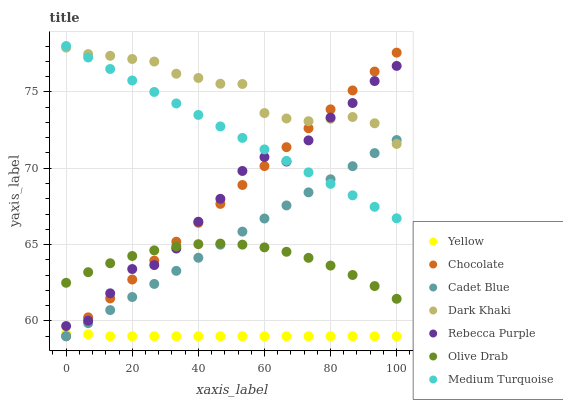Does Yellow have the minimum area under the curve?
Answer yes or no. Yes. Does Dark Khaki have the maximum area under the curve?
Answer yes or no. Yes. Does Chocolate have the minimum area under the curve?
Answer yes or no. No. Does Chocolate have the maximum area under the curve?
Answer yes or no. No. Is Chocolate the smoothest?
Answer yes or no. Yes. Is Rebecca Purple the roughest?
Answer yes or no. Yes. Is Yellow the smoothest?
Answer yes or no. No. Is Yellow the roughest?
Answer yes or no. No. Does Cadet Blue have the lowest value?
Answer yes or no. Yes. Does Dark Khaki have the lowest value?
Answer yes or no. No. Does Medium Turquoise have the highest value?
Answer yes or no. Yes. Does Chocolate have the highest value?
Answer yes or no. No. Is Yellow less than Olive Drab?
Answer yes or no. Yes. Is Rebecca Purple greater than Cadet Blue?
Answer yes or no. Yes. Does Rebecca Purple intersect Olive Drab?
Answer yes or no. Yes. Is Rebecca Purple less than Olive Drab?
Answer yes or no. No. Is Rebecca Purple greater than Olive Drab?
Answer yes or no. No. Does Yellow intersect Olive Drab?
Answer yes or no. No. 